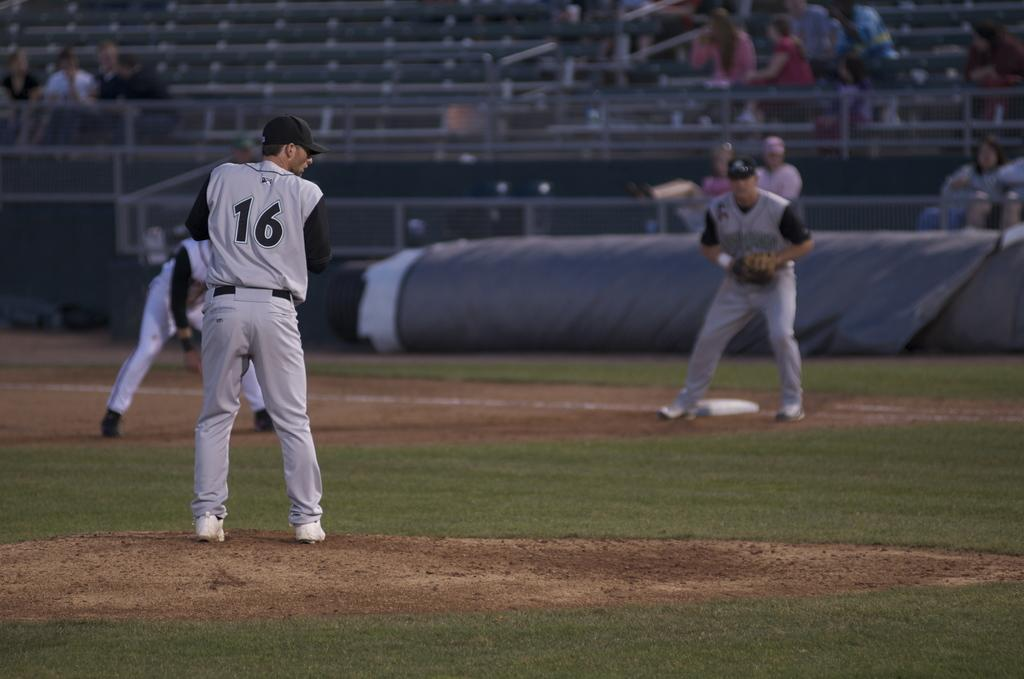What are the three persons in the image doing? The three persons are playing on the ground. What type of surface are they playing on? There is grass on the ground where they are playing. What can be seen in the background of the image? There are chairs in the background. Are there any other people in the image besides the three playing on the ground? Yes, there are persons on some cars in the image. What type of canvas is being used by the daughter in the image? There is no daughter or canvas present in the image. What type of beef is being served at the event in the image? There is no event or beef mentioned in the image. 